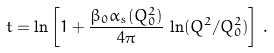<formula> <loc_0><loc_0><loc_500><loc_500>t = \ln \left [ 1 + \frac { \beta _ { 0 } \alpha _ { s } ( Q _ { 0 } ^ { 2 } ) } { 4 \pi } \, \ln ( Q ^ { 2 } / Q _ { 0 } ^ { 2 } ) \right ] \, .</formula> 